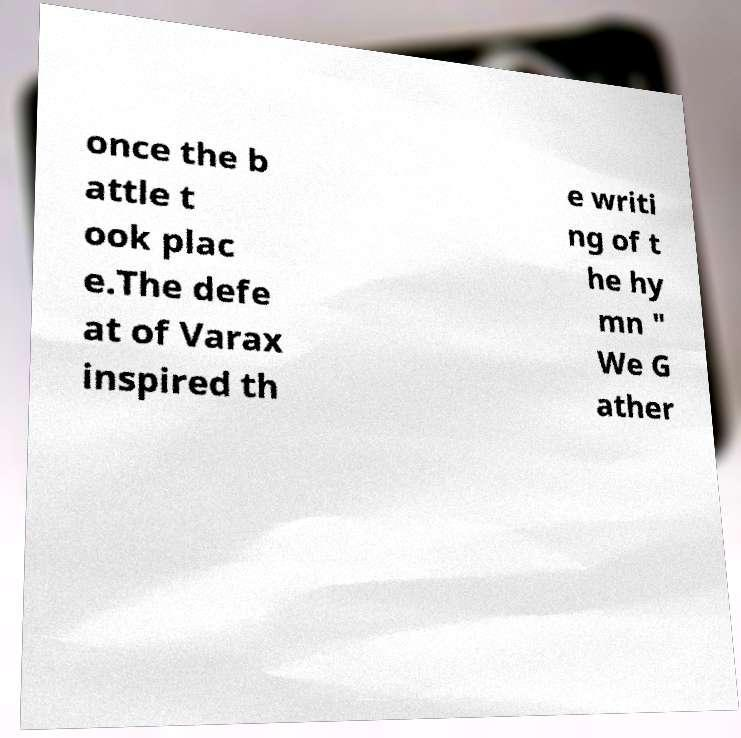There's text embedded in this image that I need extracted. Can you transcribe it verbatim? once the b attle t ook plac e.The defe at of Varax inspired th e writi ng of t he hy mn " We G ather 